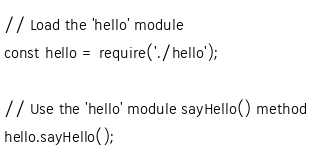Convert code to text. <code><loc_0><loc_0><loc_500><loc_500><_JavaScript_>// Load the 'hello' module
const hello = require('./hello');

// Use the 'hello' module sayHello() method
hello.sayHello();</code> 